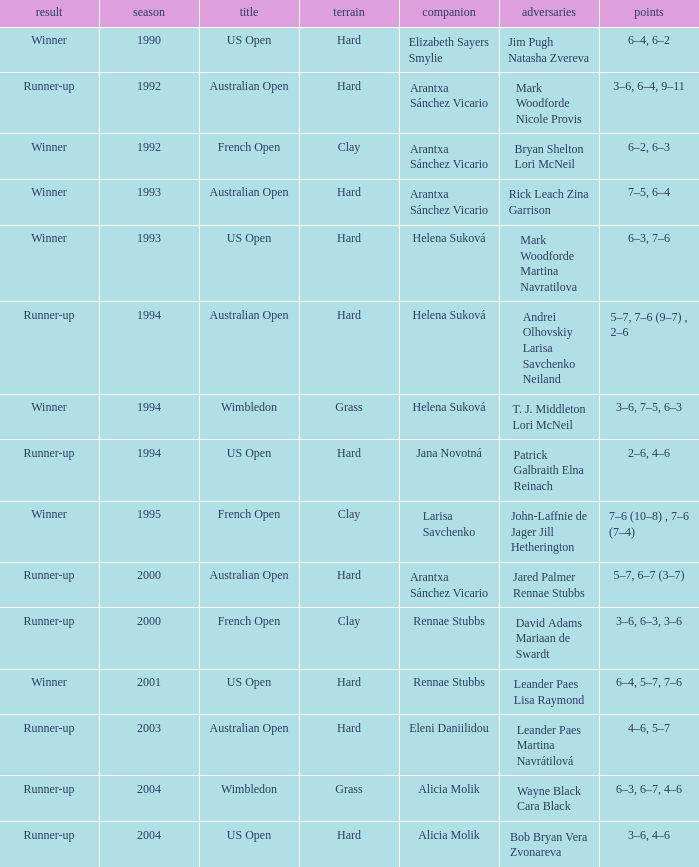Who was the Partner that was a winner, a Year smaller than 1993, and a Score of 6–4, 6–2? Elizabeth Sayers Smylie. 